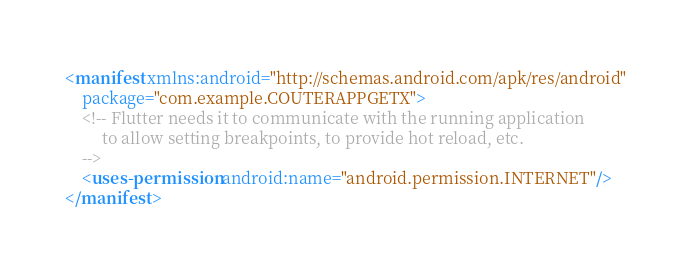<code> <loc_0><loc_0><loc_500><loc_500><_XML_><manifest xmlns:android="http://schemas.android.com/apk/res/android"
    package="com.example.COUTERAPPGETX">
    <!-- Flutter needs it to communicate with the running application
         to allow setting breakpoints, to provide hot reload, etc.
    -->
    <uses-permission android:name="android.permission.INTERNET"/>
</manifest>
</code> 